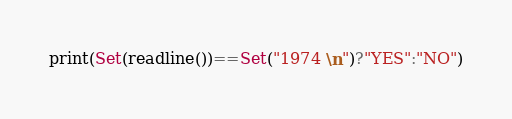<code> <loc_0><loc_0><loc_500><loc_500><_Julia_>print(Set(readline())==Set("1974 \n")?"YES":"NO")</code> 